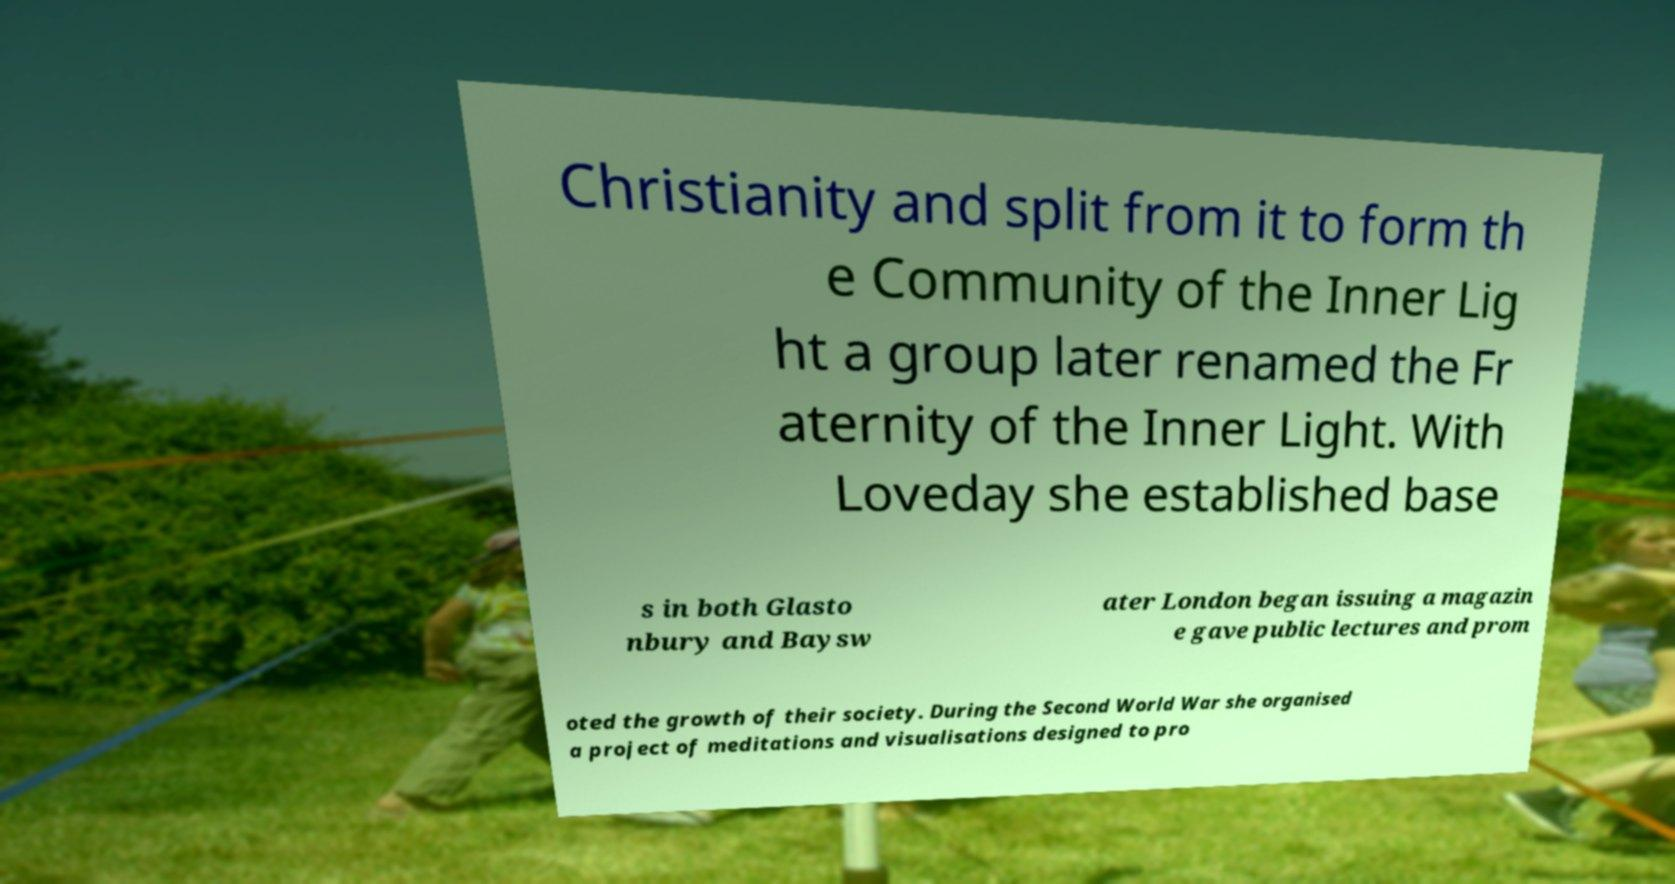There's text embedded in this image that I need extracted. Can you transcribe it verbatim? Christianity and split from it to form th e Community of the Inner Lig ht a group later renamed the Fr aternity of the Inner Light. With Loveday she established base s in both Glasto nbury and Baysw ater London began issuing a magazin e gave public lectures and prom oted the growth of their society. During the Second World War she organised a project of meditations and visualisations designed to pro 